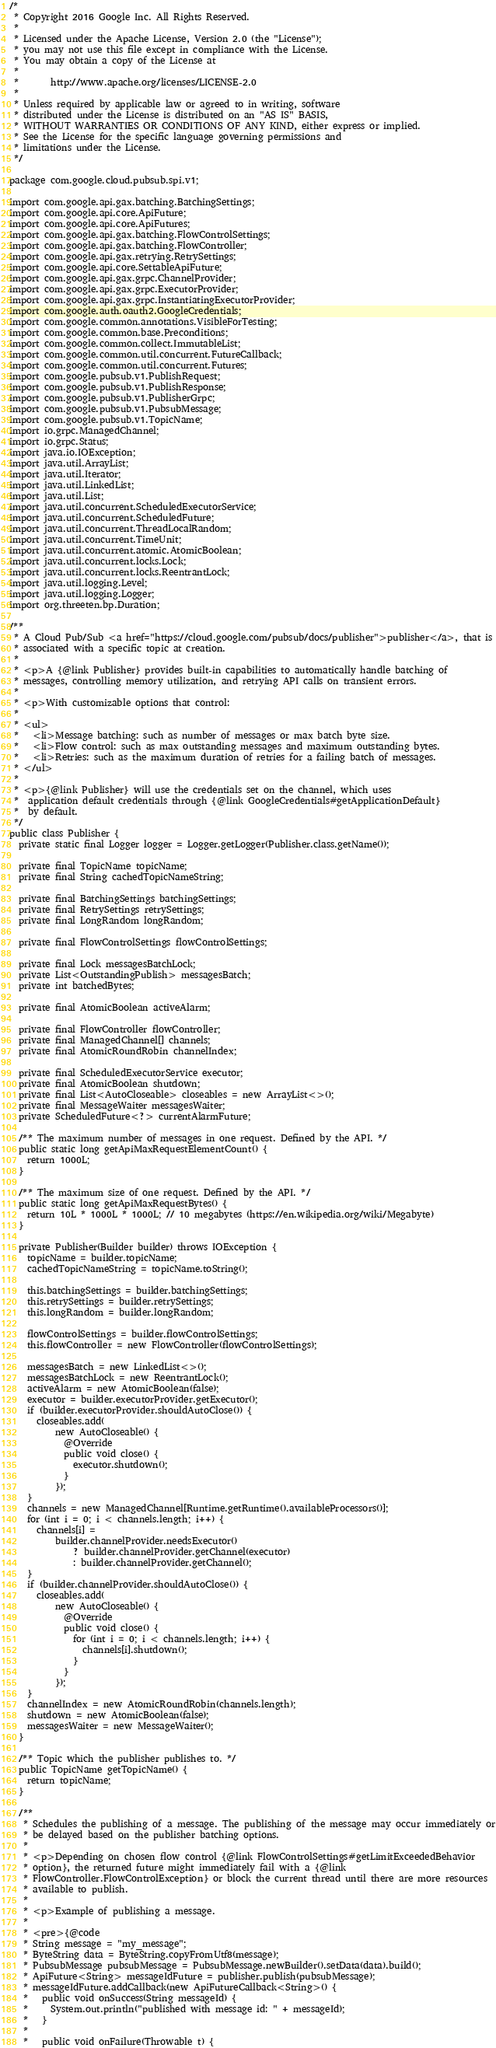Convert code to text. <code><loc_0><loc_0><loc_500><loc_500><_Java_>/*
 * Copyright 2016 Google Inc. All Rights Reserved.
 *
 * Licensed under the Apache License, Version 2.0 (the "License");
 * you may not use this file except in compliance with the License.
 * You may obtain a copy of the License at
 *
 *       http://www.apache.org/licenses/LICENSE-2.0
 *
 * Unless required by applicable law or agreed to in writing, software
 * distributed under the License is distributed on an "AS IS" BASIS,
 * WITHOUT WARRANTIES OR CONDITIONS OF ANY KIND, either express or implied.
 * See the License for the specific language governing permissions and
 * limitations under the License.
 */

package com.google.cloud.pubsub.spi.v1;

import com.google.api.gax.batching.BatchingSettings;
import com.google.api.core.ApiFuture;
import com.google.api.core.ApiFutures;
import com.google.api.gax.batching.FlowControlSettings;
import com.google.api.gax.batching.FlowController;
import com.google.api.gax.retrying.RetrySettings;
import com.google.api.core.SettableApiFuture;
import com.google.api.gax.grpc.ChannelProvider;
import com.google.api.gax.grpc.ExecutorProvider;
import com.google.api.gax.grpc.InstantiatingExecutorProvider;
import com.google.auth.oauth2.GoogleCredentials;
import com.google.common.annotations.VisibleForTesting;
import com.google.common.base.Preconditions;
import com.google.common.collect.ImmutableList;
import com.google.common.util.concurrent.FutureCallback;
import com.google.common.util.concurrent.Futures;
import com.google.pubsub.v1.PublishRequest;
import com.google.pubsub.v1.PublishResponse;
import com.google.pubsub.v1.PublisherGrpc;
import com.google.pubsub.v1.PubsubMessage;
import com.google.pubsub.v1.TopicName;
import io.grpc.ManagedChannel;
import io.grpc.Status;
import java.io.IOException;
import java.util.ArrayList;
import java.util.Iterator;
import java.util.LinkedList;
import java.util.List;
import java.util.concurrent.ScheduledExecutorService;
import java.util.concurrent.ScheduledFuture;
import java.util.concurrent.ThreadLocalRandom;
import java.util.concurrent.TimeUnit;
import java.util.concurrent.atomic.AtomicBoolean;
import java.util.concurrent.locks.Lock;
import java.util.concurrent.locks.ReentrantLock;
import java.util.logging.Level;
import java.util.logging.Logger;
import org.threeten.bp.Duration;

/**
 * A Cloud Pub/Sub <a href="https://cloud.google.com/pubsub/docs/publisher">publisher</a>, that is
 * associated with a specific topic at creation.
 *
 * <p>A {@link Publisher} provides built-in capabilities to automatically handle batching of
 * messages, controlling memory utilization, and retrying API calls on transient errors.
 *
 * <p>With customizable options that control:
 *
 * <ul>
 *   <li>Message batching: such as number of messages or max batch byte size.
 *   <li>Flow control: such as max outstanding messages and maximum outstanding bytes.
 *   <li>Retries: such as the maximum duration of retries for a failing batch of messages.
 * </ul>
 *
 * <p>{@link Publisher} will use the credentials set on the channel, which uses
 *  application default credentials through {@link GoogleCredentials#getApplicationDefault}
 *  by default.
 */
public class Publisher {
  private static final Logger logger = Logger.getLogger(Publisher.class.getName());

  private final TopicName topicName;
  private final String cachedTopicNameString;

  private final BatchingSettings batchingSettings;
  private final RetrySettings retrySettings;
  private final LongRandom longRandom;

  private final FlowControlSettings flowControlSettings;

  private final Lock messagesBatchLock;
  private List<OutstandingPublish> messagesBatch;
  private int batchedBytes;

  private final AtomicBoolean activeAlarm;

  private final FlowController flowController;
  private final ManagedChannel[] channels;
  private final AtomicRoundRobin channelIndex;

  private final ScheduledExecutorService executor;
  private final AtomicBoolean shutdown;
  private final List<AutoCloseable> closeables = new ArrayList<>();
  private final MessageWaiter messagesWaiter;
  private ScheduledFuture<?> currentAlarmFuture;

  /** The maximum number of messages in one request. Defined by the API. */
  public static long getApiMaxRequestElementCount() {
    return 1000L;
  }

  /** The maximum size of one request. Defined by the API. */
  public static long getApiMaxRequestBytes() {
    return 10L * 1000L * 1000L; // 10 megabytes (https://en.wikipedia.org/wiki/Megabyte)
  }

  private Publisher(Builder builder) throws IOException {
    topicName = builder.topicName;
    cachedTopicNameString = topicName.toString();

    this.batchingSettings = builder.batchingSettings;
    this.retrySettings = builder.retrySettings;
    this.longRandom = builder.longRandom;

    flowControlSettings = builder.flowControlSettings;
    this.flowController = new FlowController(flowControlSettings);

    messagesBatch = new LinkedList<>();
    messagesBatchLock = new ReentrantLock();
    activeAlarm = new AtomicBoolean(false);
    executor = builder.executorProvider.getExecutor();
    if (builder.executorProvider.shouldAutoClose()) {
      closeables.add(
          new AutoCloseable() {
            @Override
            public void close() {
              executor.shutdown();
            }
          });
    }
    channels = new ManagedChannel[Runtime.getRuntime().availableProcessors()];
    for (int i = 0; i < channels.length; i++) {
      channels[i] =
          builder.channelProvider.needsExecutor()
              ? builder.channelProvider.getChannel(executor)
              : builder.channelProvider.getChannel();
    }
    if (builder.channelProvider.shouldAutoClose()) {
      closeables.add(
          new AutoCloseable() {
            @Override
            public void close() {
              for (int i = 0; i < channels.length; i++) {
                channels[i].shutdown();
              }
            }
          });
    }
    channelIndex = new AtomicRoundRobin(channels.length);
    shutdown = new AtomicBoolean(false);
    messagesWaiter = new MessageWaiter();
  }

  /** Topic which the publisher publishes to. */
  public TopicName getTopicName() {
    return topicName;
  }

  /**
   * Schedules the publishing of a message. The publishing of the message may occur immediately or
   * be delayed based on the publisher batching options.
   *
   * <p>Depending on chosen flow control {@link FlowControlSettings#getLimitExceededBehavior
   * option}, the returned future might immediately fail with a {@link
   * FlowController.FlowControlException} or block the current thread until there are more resources
   * available to publish.
   *
   * <p>Example of publishing a message.
   *
   * <pre>{@code
   * String message = "my_message";
   * ByteString data = ByteString.copyFromUtf8(message);
   * PubsubMessage pubsubMessage = PubsubMessage.newBuilder().setData(data).build();
   * ApiFuture<String> messageIdFuture = publisher.publish(pubsubMessage);
   * messageIdFuture.addCallback(new ApiFutureCallback<String>() {
   *   public void onSuccess(String messageId) {
   *     System.out.println("published with message id: " + messageId);
   *   }
   *
   *   public void onFailure(Throwable t) {</code> 